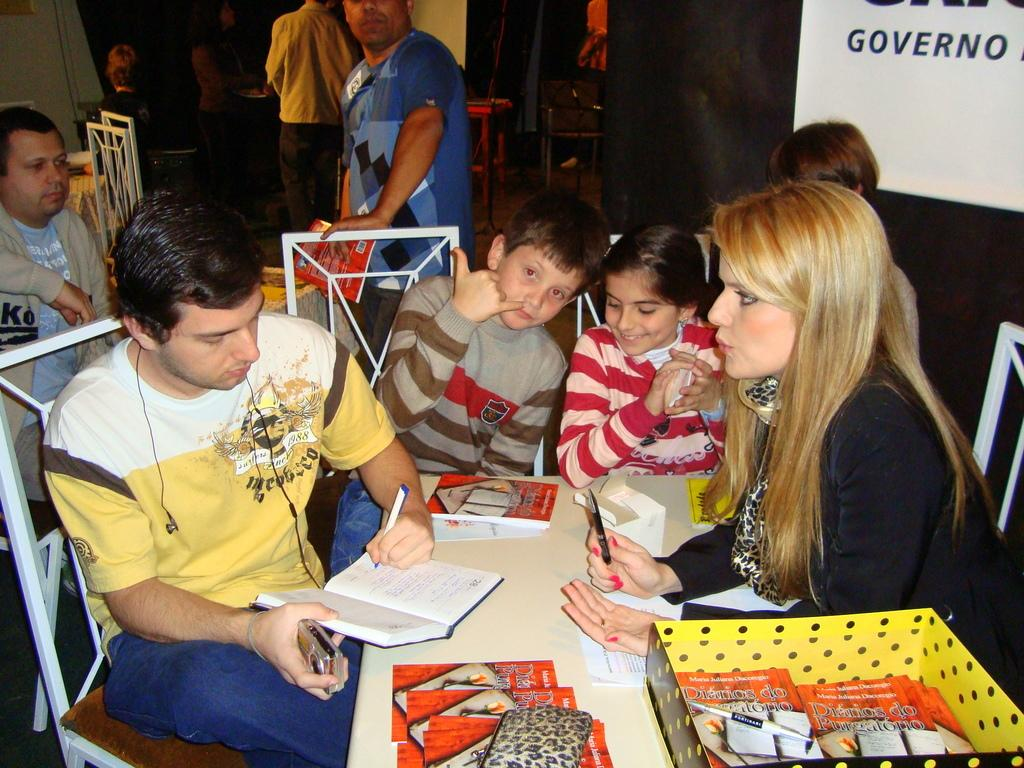<image>
Write a terse but informative summary of the picture. A book titled " Diarios Do Purgatorio" by Maria Juliana Dacoregio. 